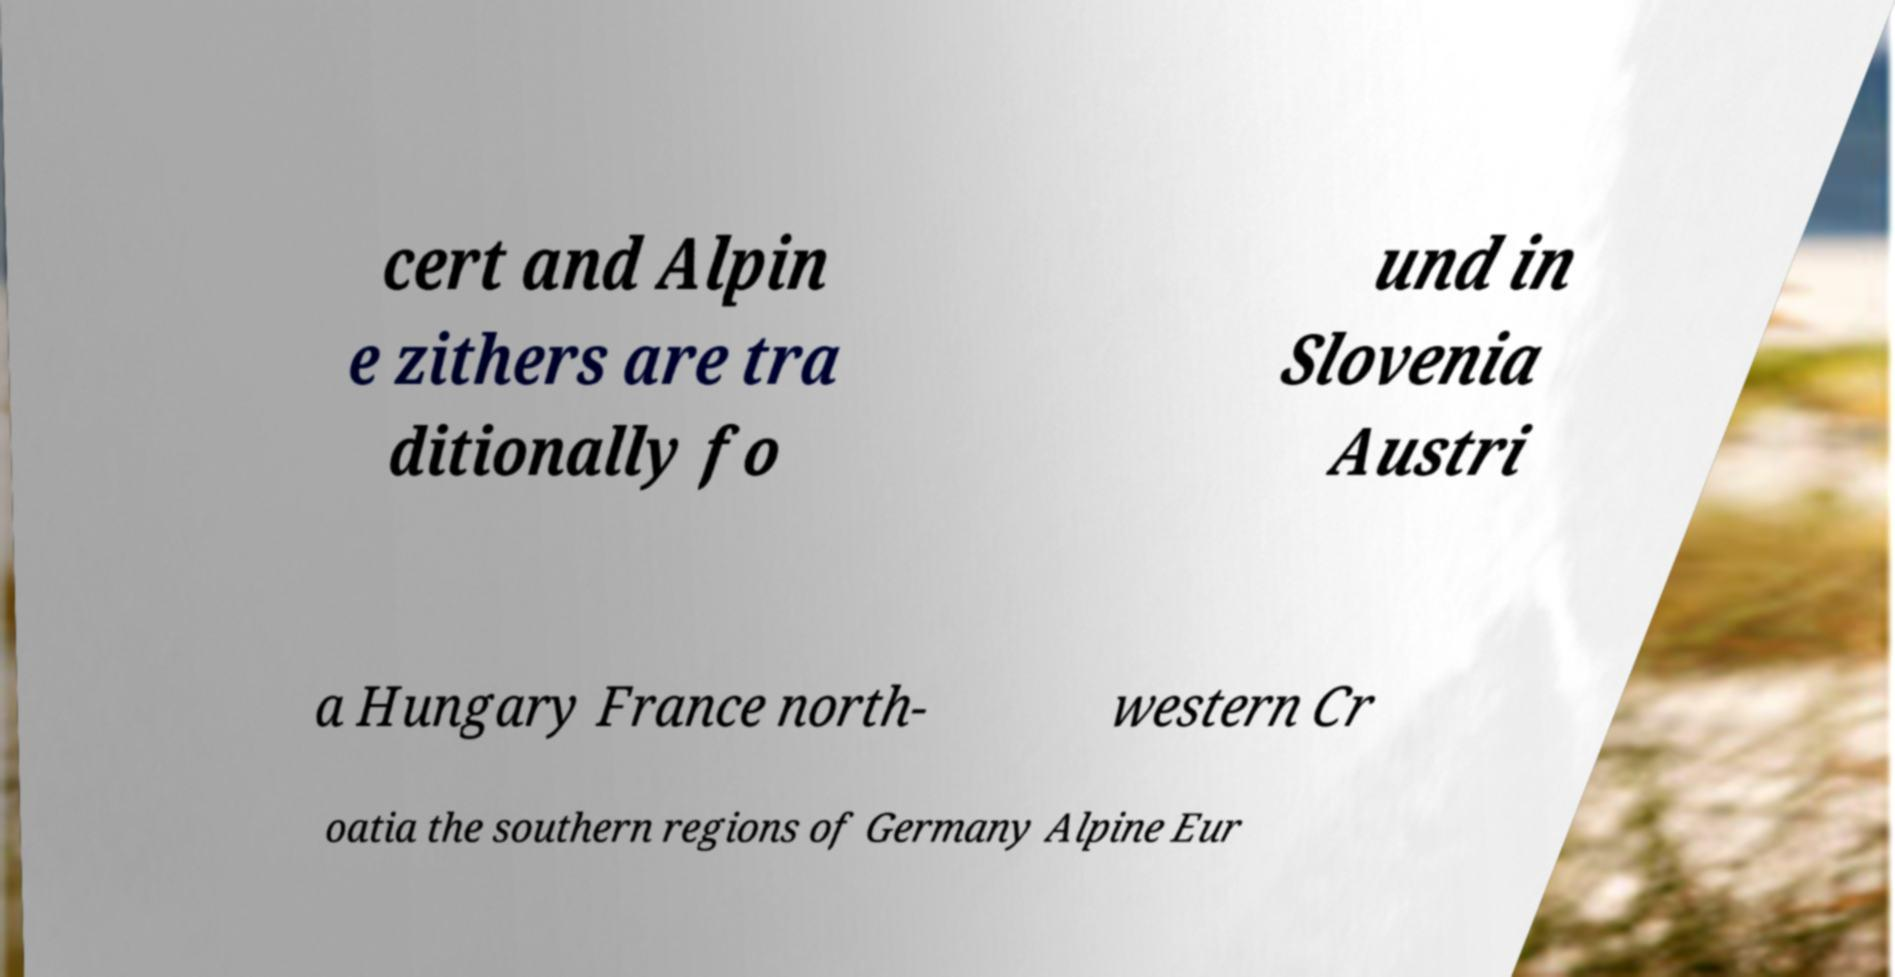Can you read and provide the text displayed in the image?This photo seems to have some interesting text. Can you extract and type it out for me? cert and Alpin e zithers are tra ditionally fo und in Slovenia Austri a Hungary France north- western Cr oatia the southern regions of Germany Alpine Eur 